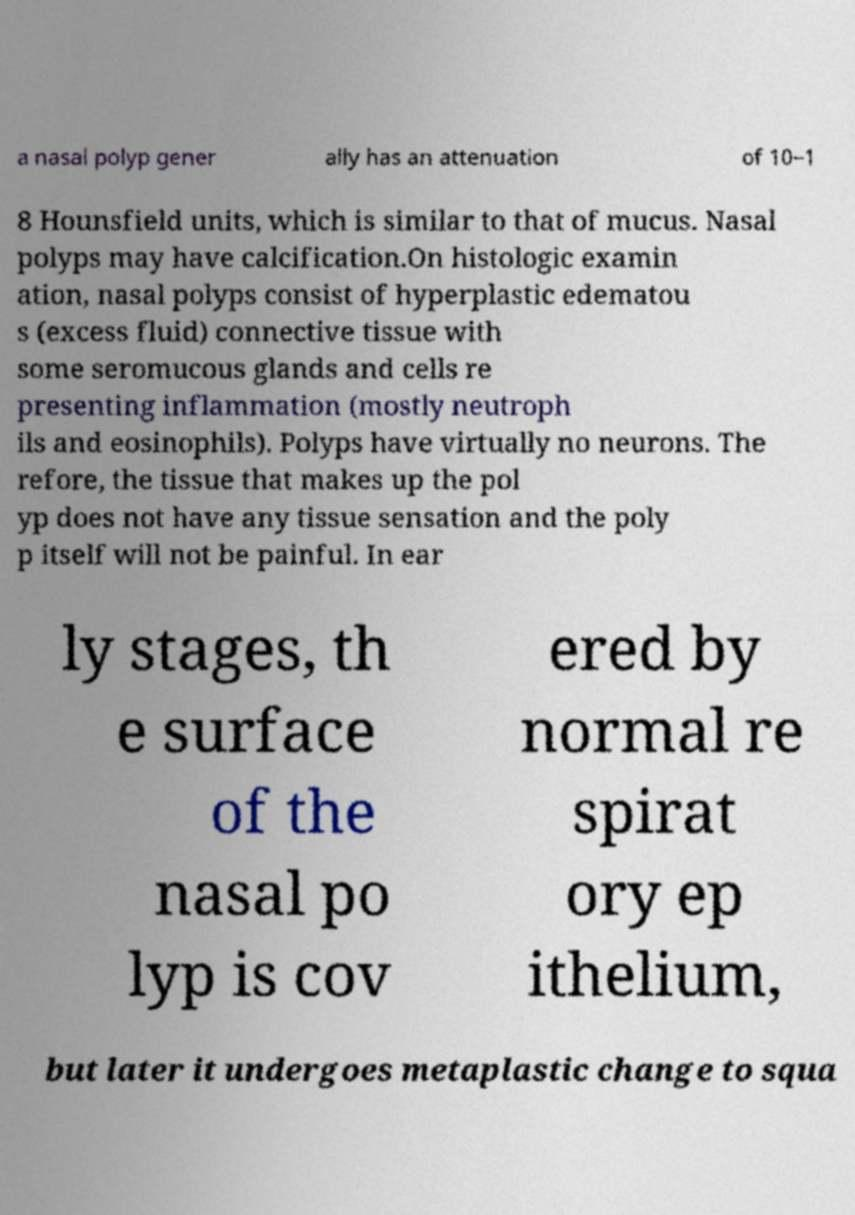What messages or text are displayed in this image? I need them in a readable, typed format. a nasal polyp gener ally has an attenuation of 10–1 8 Hounsfield units, which is similar to that of mucus. Nasal polyps may have calcification.On histologic examin ation, nasal polyps consist of hyperplastic edematou s (excess fluid) connective tissue with some seromucous glands and cells re presenting inflammation (mostly neutroph ils and eosinophils). Polyps have virtually no neurons. The refore, the tissue that makes up the pol yp does not have any tissue sensation and the poly p itself will not be painful. In ear ly stages, th e surface of the nasal po lyp is cov ered by normal re spirat ory ep ithelium, but later it undergoes metaplastic change to squa 